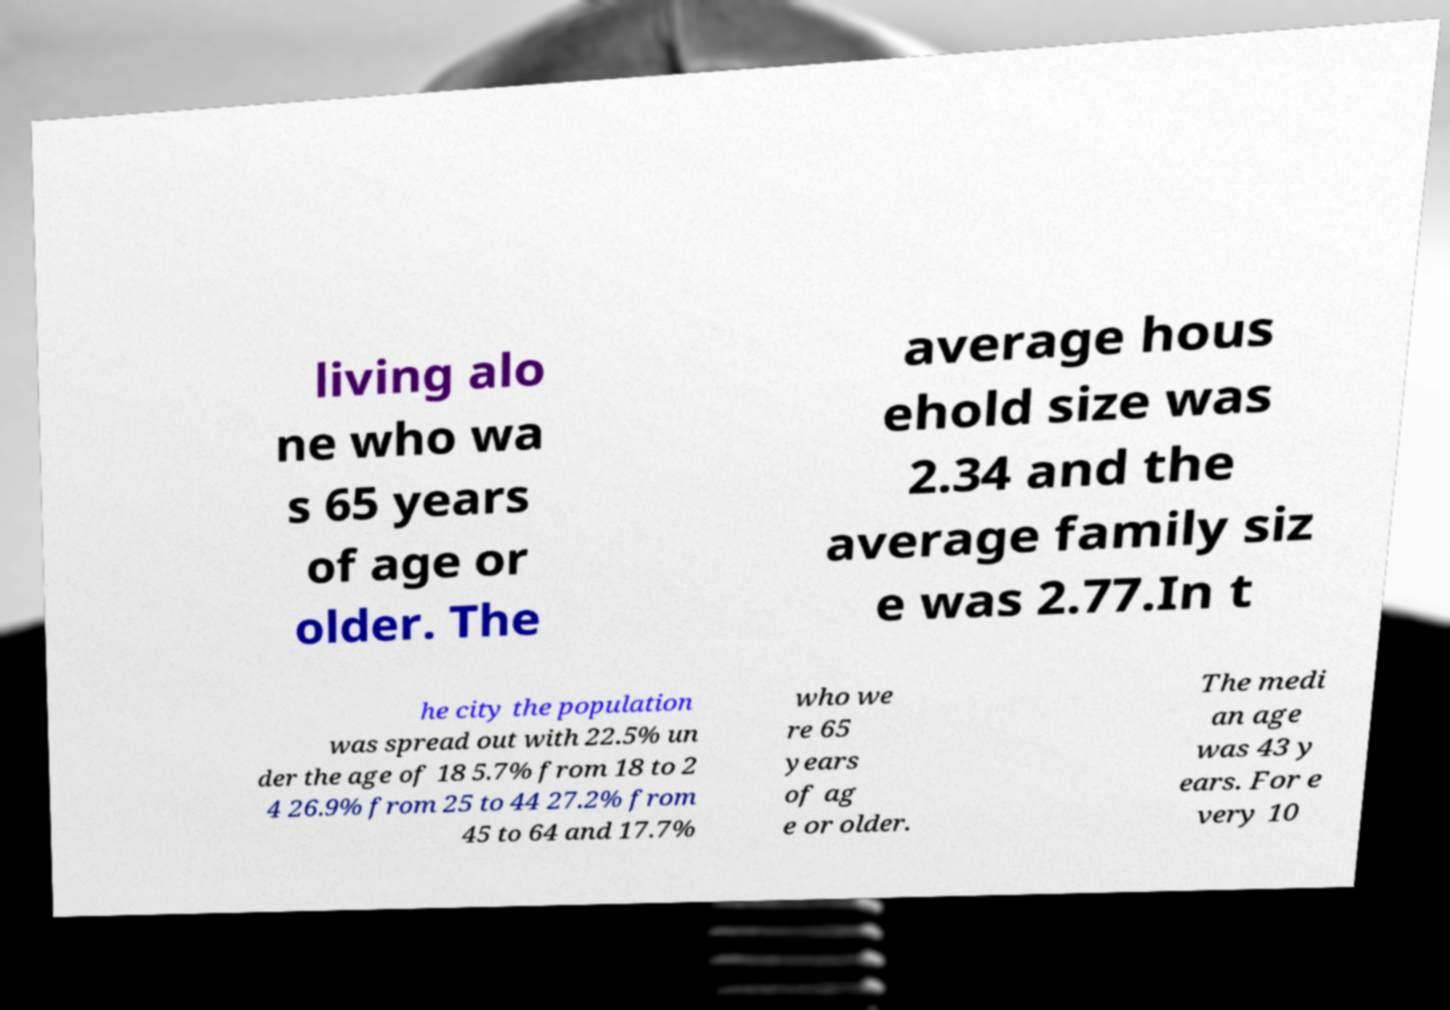Can you accurately transcribe the text from the provided image for me? living alo ne who wa s 65 years of age or older. The average hous ehold size was 2.34 and the average family siz e was 2.77.In t he city the population was spread out with 22.5% un der the age of 18 5.7% from 18 to 2 4 26.9% from 25 to 44 27.2% from 45 to 64 and 17.7% who we re 65 years of ag e or older. The medi an age was 43 y ears. For e very 10 